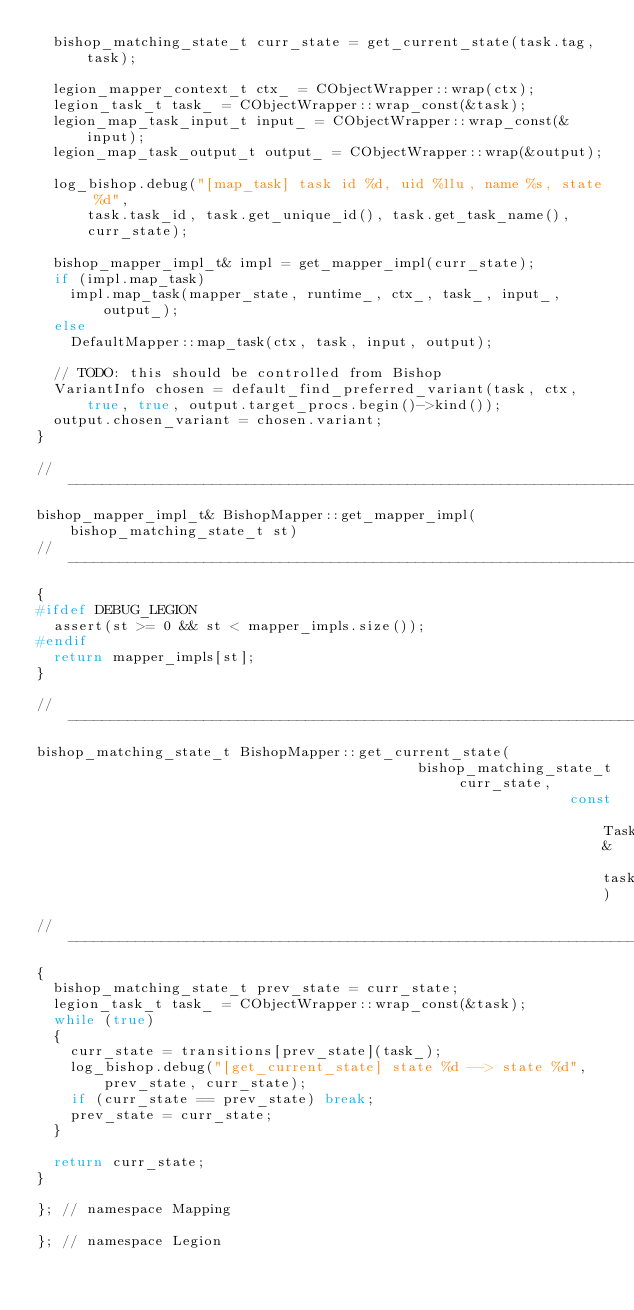Convert code to text. <code><loc_0><loc_0><loc_500><loc_500><_C++_>  bishop_matching_state_t curr_state = get_current_state(task.tag, task);

  legion_mapper_context_t ctx_ = CObjectWrapper::wrap(ctx);
  legion_task_t task_ = CObjectWrapper::wrap_const(&task);
  legion_map_task_input_t input_ = CObjectWrapper::wrap_const(&input);
  legion_map_task_output_t output_ = CObjectWrapper::wrap(&output);

  log_bishop.debug("[map_task] task id %d, uid %llu, name %s, state %d",
      task.task_id, task.get_unique_id(), task.get_task_name(),
      curr_state);

  bishop_mapper_impl_t& impl = get_mapper_impl(curr_state);
  if (impl.map_task)
    impl.map_task(mapper_state, runtime_, ctx_, task_, input_, output_);
  else
    DefaultMapper::map_task(ctx, task, input, output);

  // TODO: this should be controlled from Bishop
  VariantInfo chosen = default_find_preferred_variant(task, ctx,
      true, true, output.target_procs.begin()->kind());
  output.chosen_variant = chosen.variant;
}

//------------------------------------------------------------------------------
bishop_mapper_impl_t& BishopMapper::get_mapper_impl(bishop_matching_state_t st)
//------------------------------------------------------------------------------
{
#ifdef DEBUG_LEGION
  assert(st >= 0 && st < mapper_impls.size());
#endif
  return mapper_impls[st];
}

//------------------------------------------------------------------------------
bishop_matching_state_t BishopMapper::get_current_state(
                                             bishop_matching_state_t curr_state,
                                                               const Task& task)
//------------------------------------------------------------------------------
{
  bishop_matching_state_t prev_state = curr_state;
  legion_task_t task_ = CObjectWrapper::wrap_const(&task);
  while (true)
  {
    curr_state = transitions[prev_state](task_);
    log_bishop.debug("[get_current_state] state %d --> state %d",
        prev_state, curr_state);
    if (curr_state == prev_state) break;
    prev_state = curr_state;
  }

  return curr_state;
}

}; // namespace Mapping

}; // namespace Legion
</code> 